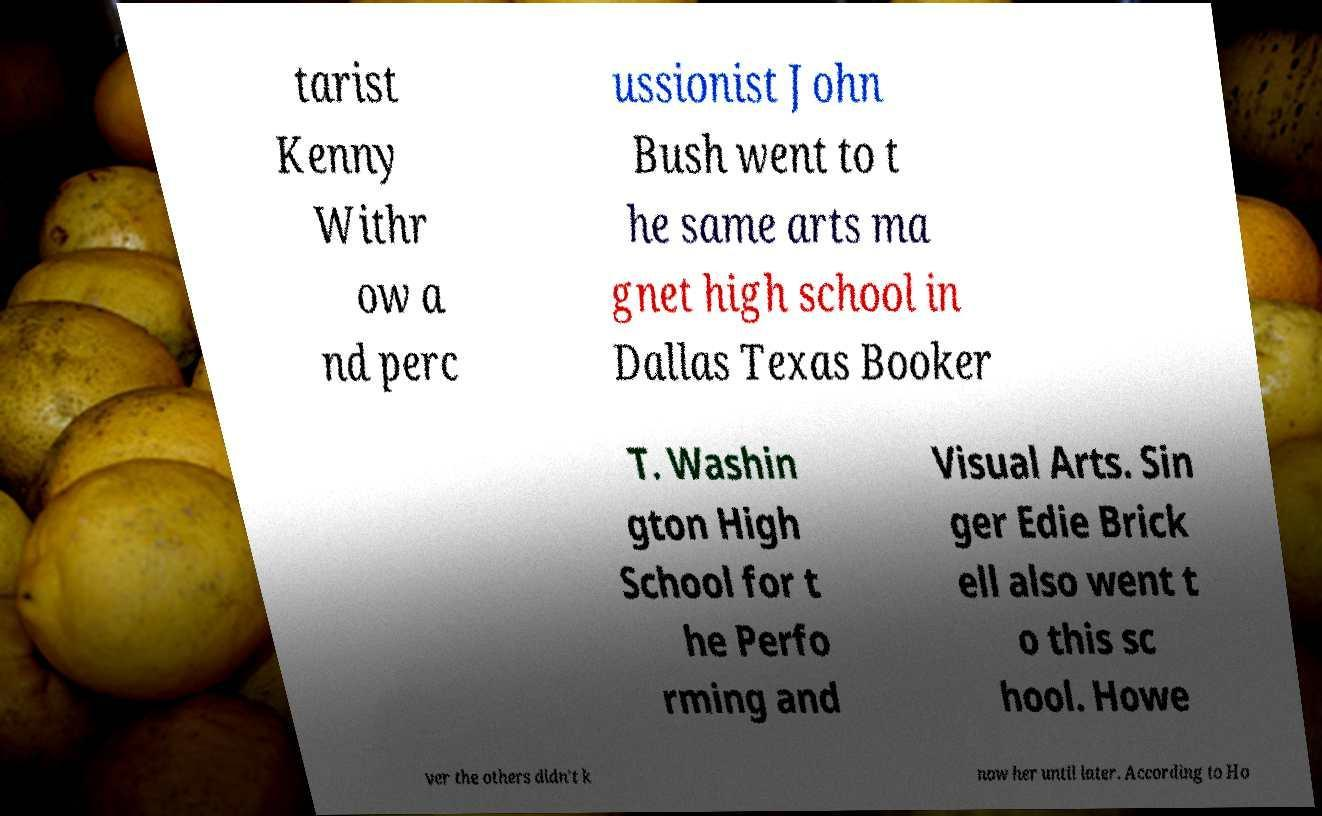Could you extract and type out the text from this image? tarist Kenny Withr ow a nd perc ussionist John Bush went to t he same arts ma gnet high school in Dallas Texas Booker T. Washin gton High School for t he Perfo rming and Visual Arts. Sin ger Edie Brick ell also went t o this sc hool. Howe ver the others didn't k now her until later. According to Ho 